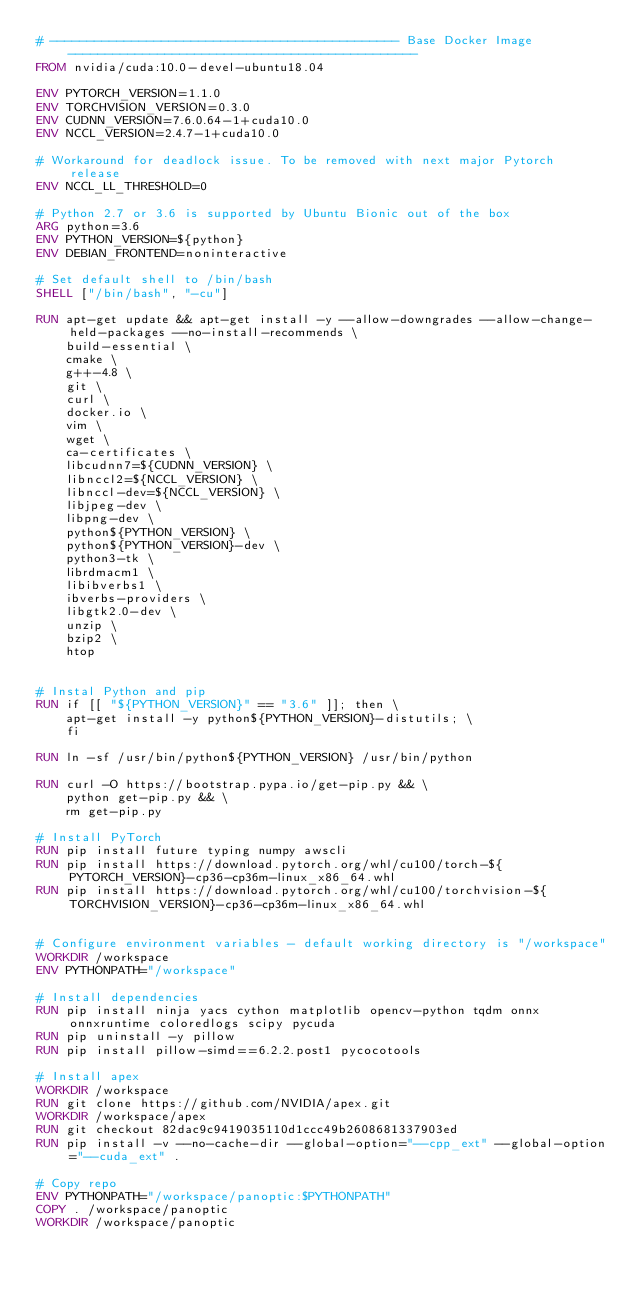Convert code to text. <code><loc_0><loc_0><loc_500><loc_500><_Dockerfile_># ----------------------------------------------- Base Docker Image -----------------------------------------------
FROM nvidia/cuda:10.0-devel-ubuntu18.04

ENV PYTORCH_VERSION=1.1.0
ENV TORCHVISION_VERSION=0.3.0
ENV CUDNN_VERSION=7.6.0.64-1+cuda10.0
ENV NCCL_VERSION=2.4.7-1+cuda10.0

# Workaround for deadlock issue. To be removed with next major Pytorch release
ENV NCCL_LL_THRESHOLD=0

# Python 2.7 or 3.6 is supported by Ubuntu Bionic out of the box
ARG python=3.6
ENV PYTHON_VERSION=${python}
ENV DEBIAN_FRONTEND=noninteractive

# Set default shell to /bin/bash
SHELL ["/bin/bash", "-cu"]

RUN apt-get update && apt-get install -y --allow-downgrades --allow-change-held-packages --no-install-recommends \
    build-essential \
    cmake \
    g++-4.8 \
    git \
    curl \
    docker.io \
    vim \
    wget \
    ca-certificates \
    libcudnn7=${CUDNN_VERSION} \
    libnccl2=${NCCL_VERSION} \
    libnccl-dev=${NCCL_VERSION} \
    libjpeg-dev \
    libpng-dev \
    python${PYTHON_VERSION} \
    python${PYTHON_VERSION}-dev \
    python3-tk \
    librdmacm1 \
    libibverbs1 \
    ibverbs-providers \
    libgtk2.0-dev \
    unzip \
    bzip2 \
    htop


# Instal Python and pip
RUN if [[ "${PYTHON_VERSION}" == "3.6" ]]; then \
    apt-get install -y python${PYTHON_VERSION}-distutils; \
    fi

RUN ln -sf /usr/bin/python${PYTHON_VERSION} /usr/bin/python

RUN curl -O https://bootstrap.pypa.io/get-pip.py && \
    python get-pip.py && \
    rm get-pip.py

# Install PyTorch
RUN pip install future typing numpy awscli
RUN pip install https://download.pytorch.org/whl/cu100/torch-${PYTORCH_VERSION}-cp36-cp36m-linux_x86_64.whl
RUN pip install https://download.pytorch.org/whl/cu100/torchvision-${TORCHVISION_VERSION}-cp36-cp36m-linux_x86_64.whl


# Configure environment variables - default working directory is "/workspace"
WORKDIR /workspace
ENV PYTHONPATH="/workspace"

# Install dependencies
RUN pip install ninja yacs cython matplotlib opencv-python tqdm onnx onnxruntime coloredlogs scipy pycuda
RUN pip uninstall -y pillow
RUN pip install pillow-simd==6.2.2.post1 pycocotools 

# Install apex
WORKDIR /workspace
RUN git clone https://github.com/NVIDIA/apex.git
WORKDIR /workspace/apex
RUN git checkout 82dac9c9419035110d1ccc49b2608681337903ed
RUN pip install -v --no-cache-dir --global-option="--cpp_ext" --global-option="--cuda_ext" .

# Copy repo
ENV PYTHONPATH="/workspace/panoptic:$PYTHONPATH"
COPY . /workspace/panoptic
WORKDIR /workspace/panoptic
</code> 